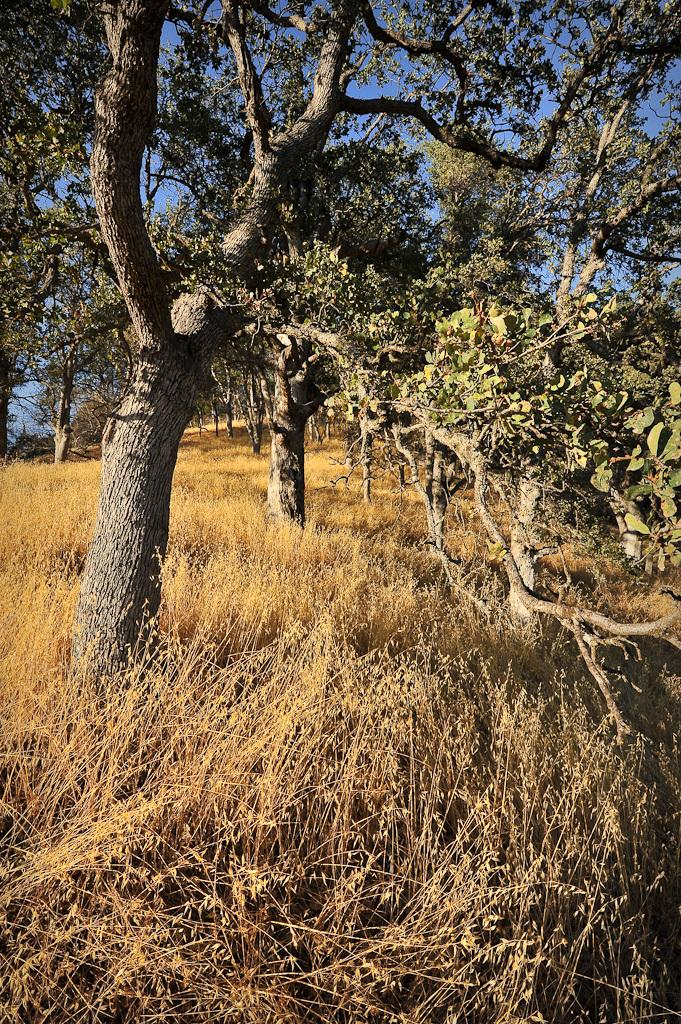What type of vegetation is in the center of the image? There are trees in the center of the image. What type of ground cover is at the bottom of the image? There is grass at the bottom of the image. What actor is performing in the history play depicted in the image? There is no actor or history play present in the image; it features trees and grass. 